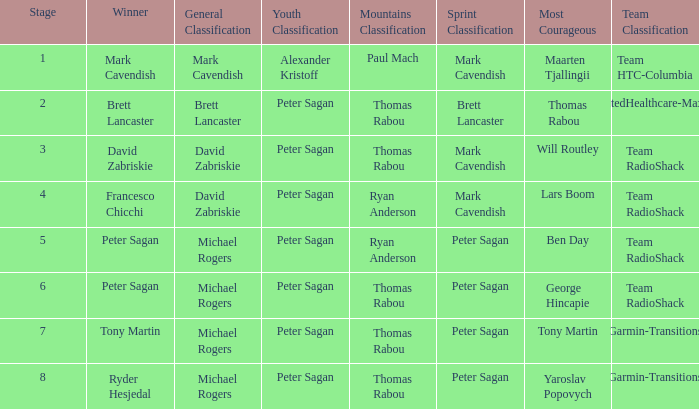When Brett Lancaster won the general classification, who won the team calssification? UnitedHealthcare-Maxxis. 